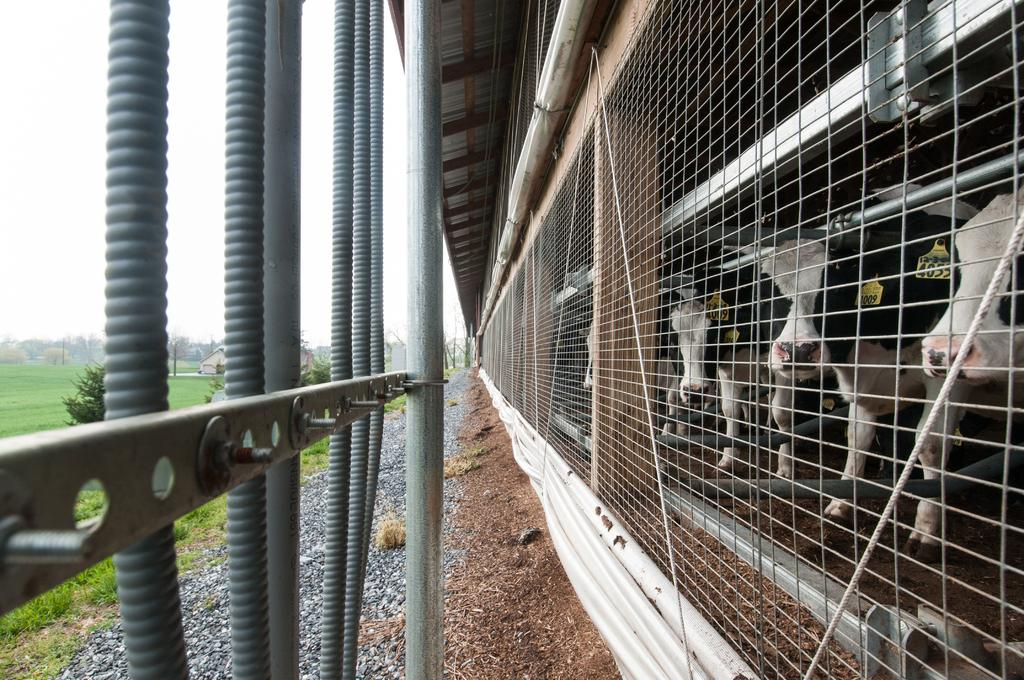What type of animals are inside the shed in the image? There are cows inside the shed in the image. What can be seen in the image that might be used for cooking? There is a grill in the image. What objects in the image are long and thin? There are rods and a pole in the image. What type of vegetation is visible in the image? There is grass in the image. What type of natural scenery is visible in the background of the image? There are trees and the sky visible in the background of the image. What type of ice is being used to cool the cows in the image? There is no ice present in the image, and the cows are not being cooled. What type of horn is visible on the cows in the image? The cows in the image do not have horns. 